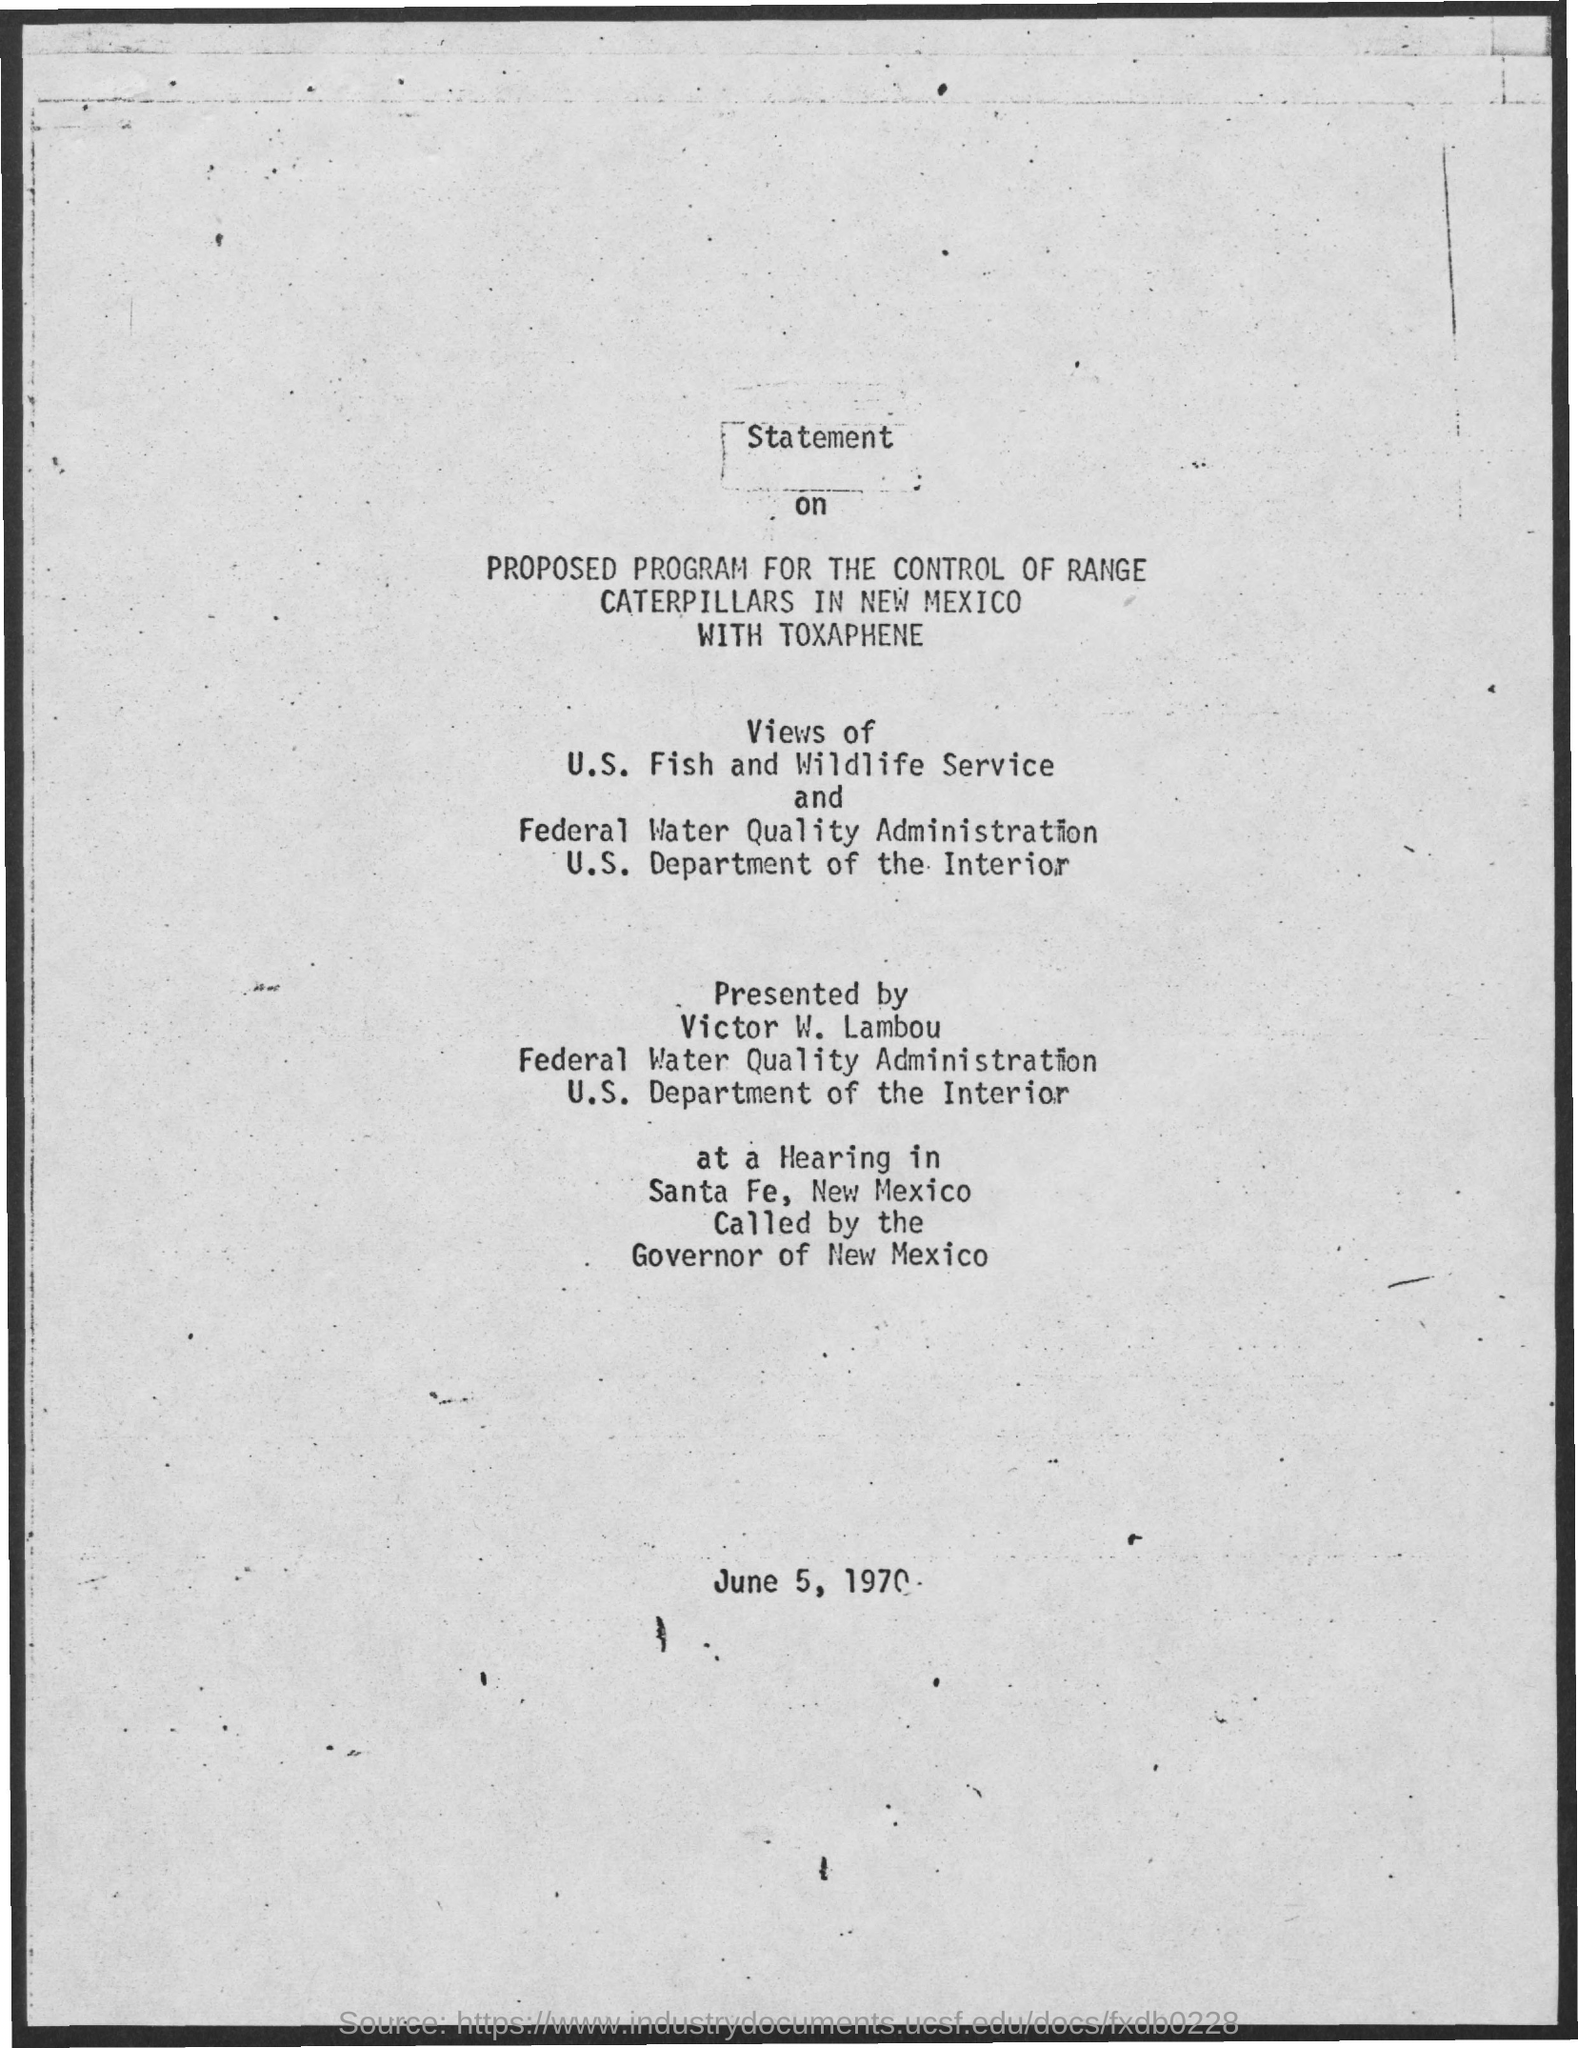Point out several critical features in this image. The date mentioned is June 5, 1970. 